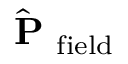Convert formula to latex. <formula><loc_0><loc_0><loc_500><loc_500>\hat { P } _ { f i e l d }</formula> 